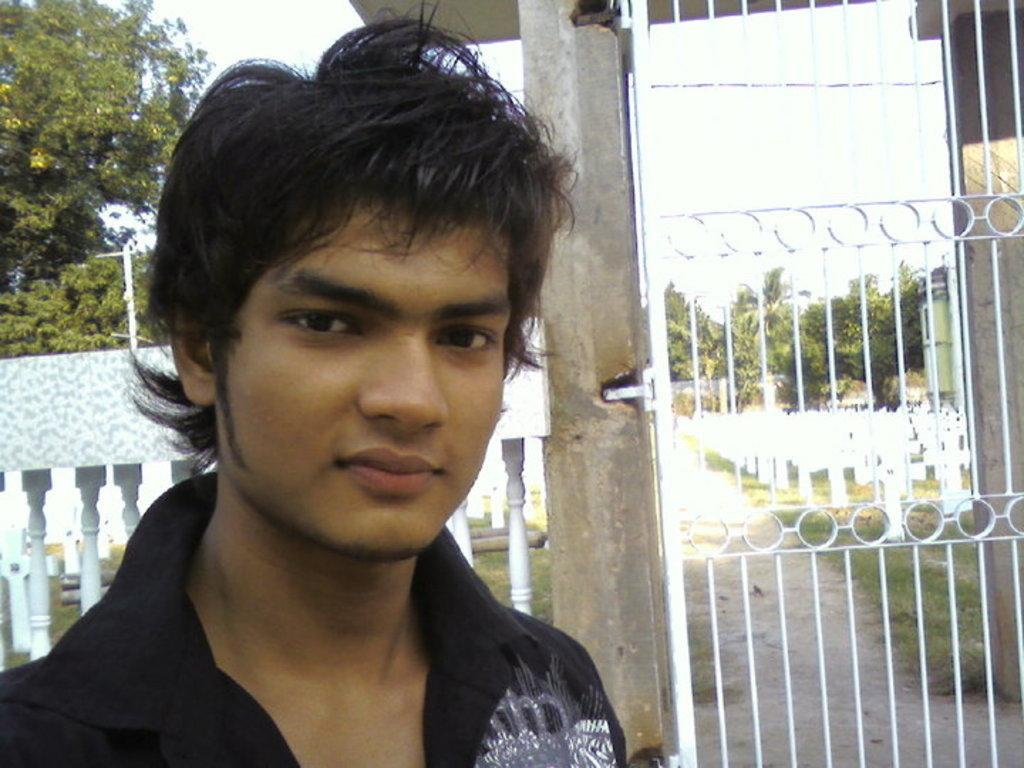Who is in the image? There is a boy in the image. What is the boy wearing? The boy is wearing a black shirt. What is the boy's facial expression? The boy is smiling. What can be seen behind the boy? There is a white color gate behind the boy. What is visible in the background of the image? Trees and the sky are visible in the background of the image. What invention is the boy demonstrating in the image? There is no invention being demonstrated in the image; the boy is simply smiling. Can you see a swing in the image? There is no swing present in the image. 